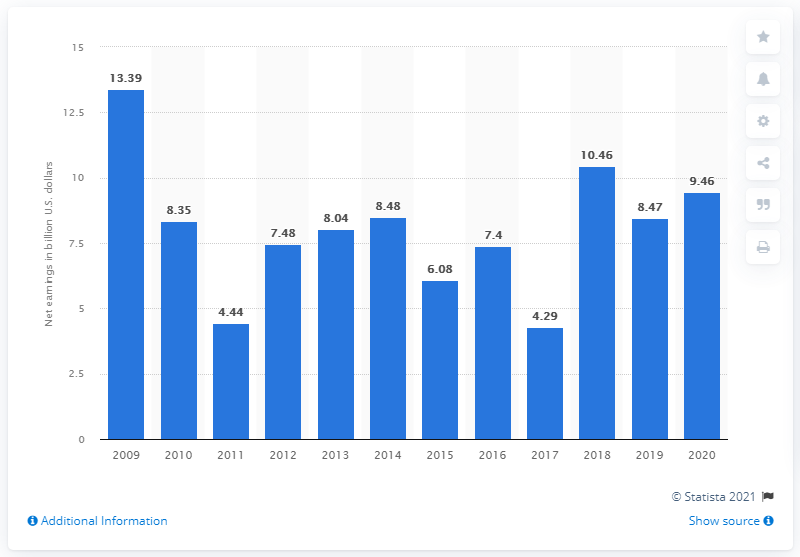Outline some significant characteristics in this image. In 2020, the net earnings of Goldman Sachs were 9.46 billion dollars. 